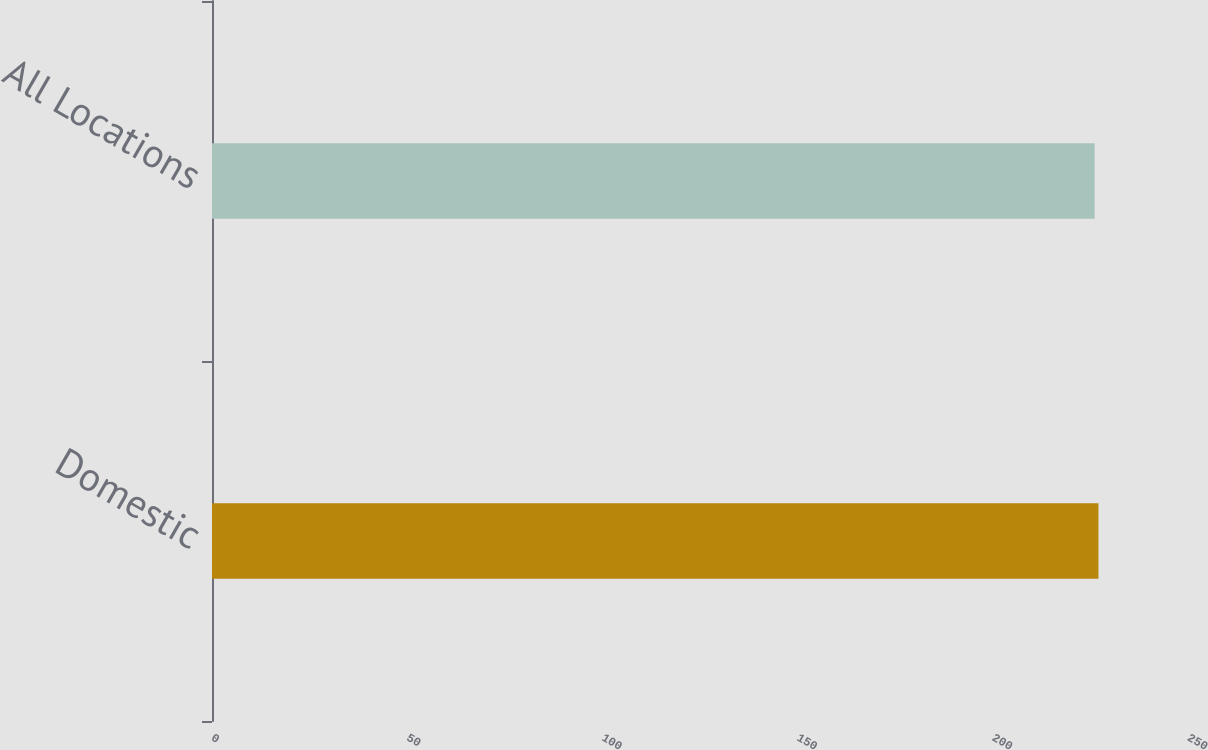<chart> <loc_0><loc_0><loc_500><loc_500><bar_chart><fcel>Domestic<fcel>All Locations<nl><fcel>227.06<fcel>226.09<nl></chart> 